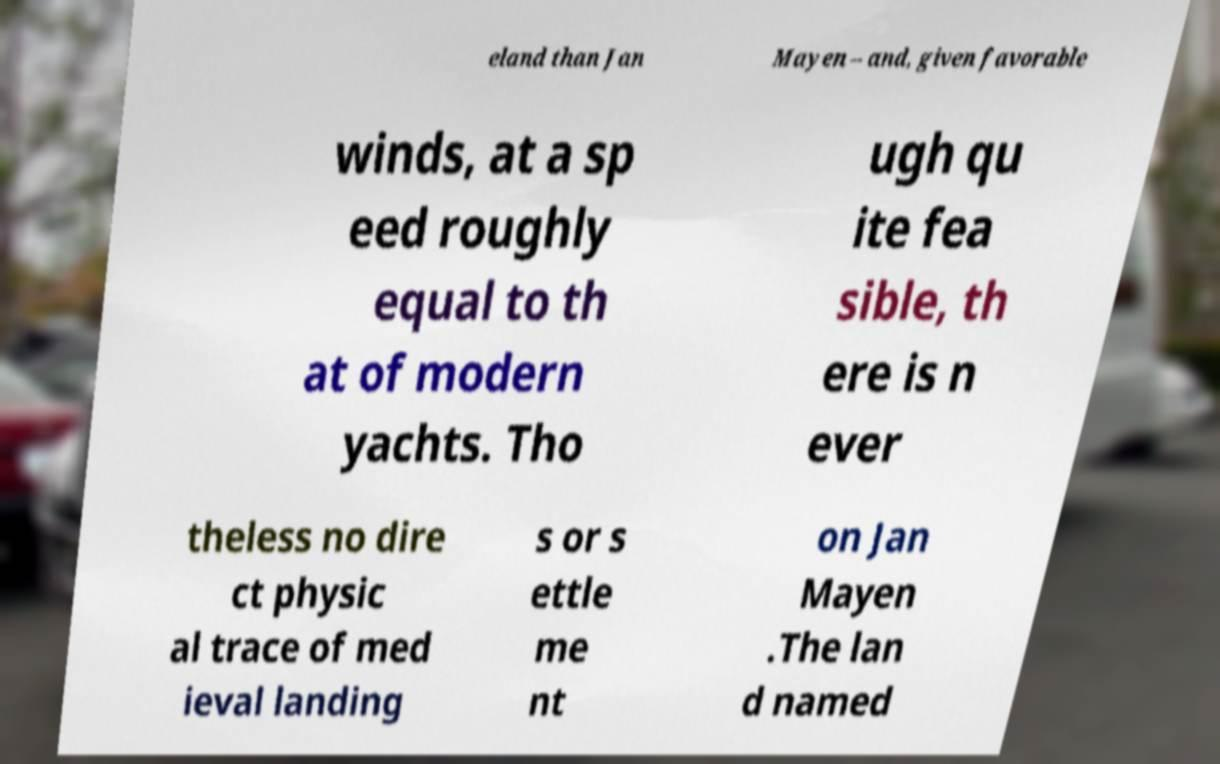Please identify and transcribe the text found in this image. eland than Jan Mayen – and, given favorable winds, at a sp eed roughly equal to th at of modern yachts. Tho ugh qu ite fea sible, th ere is n ever theless no dire ct physic al trace of med ieval landing s or s ettle me nt on Jan Mayen .The lan d named 